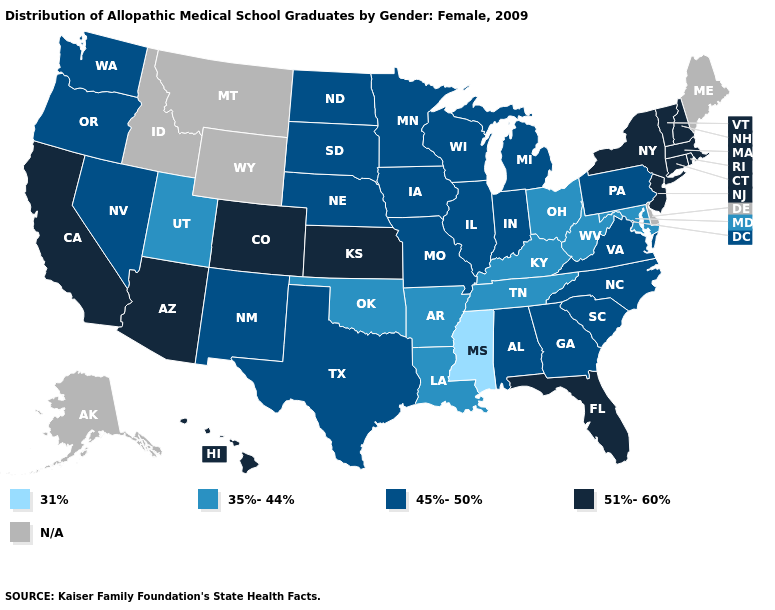Name the states that have a value in the range 51%-60%?
Give a very brief answer. Arizona, California, Colorado, Connecticut, Florida, Hawaii, Kansas, Massachusetts, New Hampshire, New Jersey, New York, Rhode Island, Vermont. What is the highest value in the USA?
Short answer required. 51%-60%. What is the lowest value in the USA?
Give a very brief answer. 31%. Does North Carolina have the lowest value in the USA?
Write a very short answer. No. What is the highest value in the USA?
Answer briefly. 51%-60%. Name the states that have a value in the range 35%-44%?
Give a very brief answer. Arkansas, Kentucky, Louisiana, Maryland, Ohio, Oklahoma, Tennessee, Utah, West Virginia. Which states have the lowest value in the South?
Quick response, please. Mississippi. Is the legend a continuous bar?
Concise answer only. No. What is the highest value in the West ?
Be succinct. 51%-60%. Name the states that have a value in the range 35%-44%?
Give a very brief answer. Arkansas, Kentucky, Louisiana, Maryland, Ohio, Oklahoma, Tennessee, Utah, West Virginia. What is the value of Hawaii?
Short answer required. 51%-60%. What is the lowest value in states that border Tennessee?
Short answer required. 31%. What is the lowest value in the MidWest?
Give a very brief answer. 35%-44%. Which states have the lowest value in the West?
Concise answer only. Utah. What is the highest value in states that border Delaware?
Short answer required. 51%-60%. 